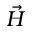Convert formula to latex. <formula><loc_0><loc_0><loc_500><loc_500>\vec { H }</formula> 